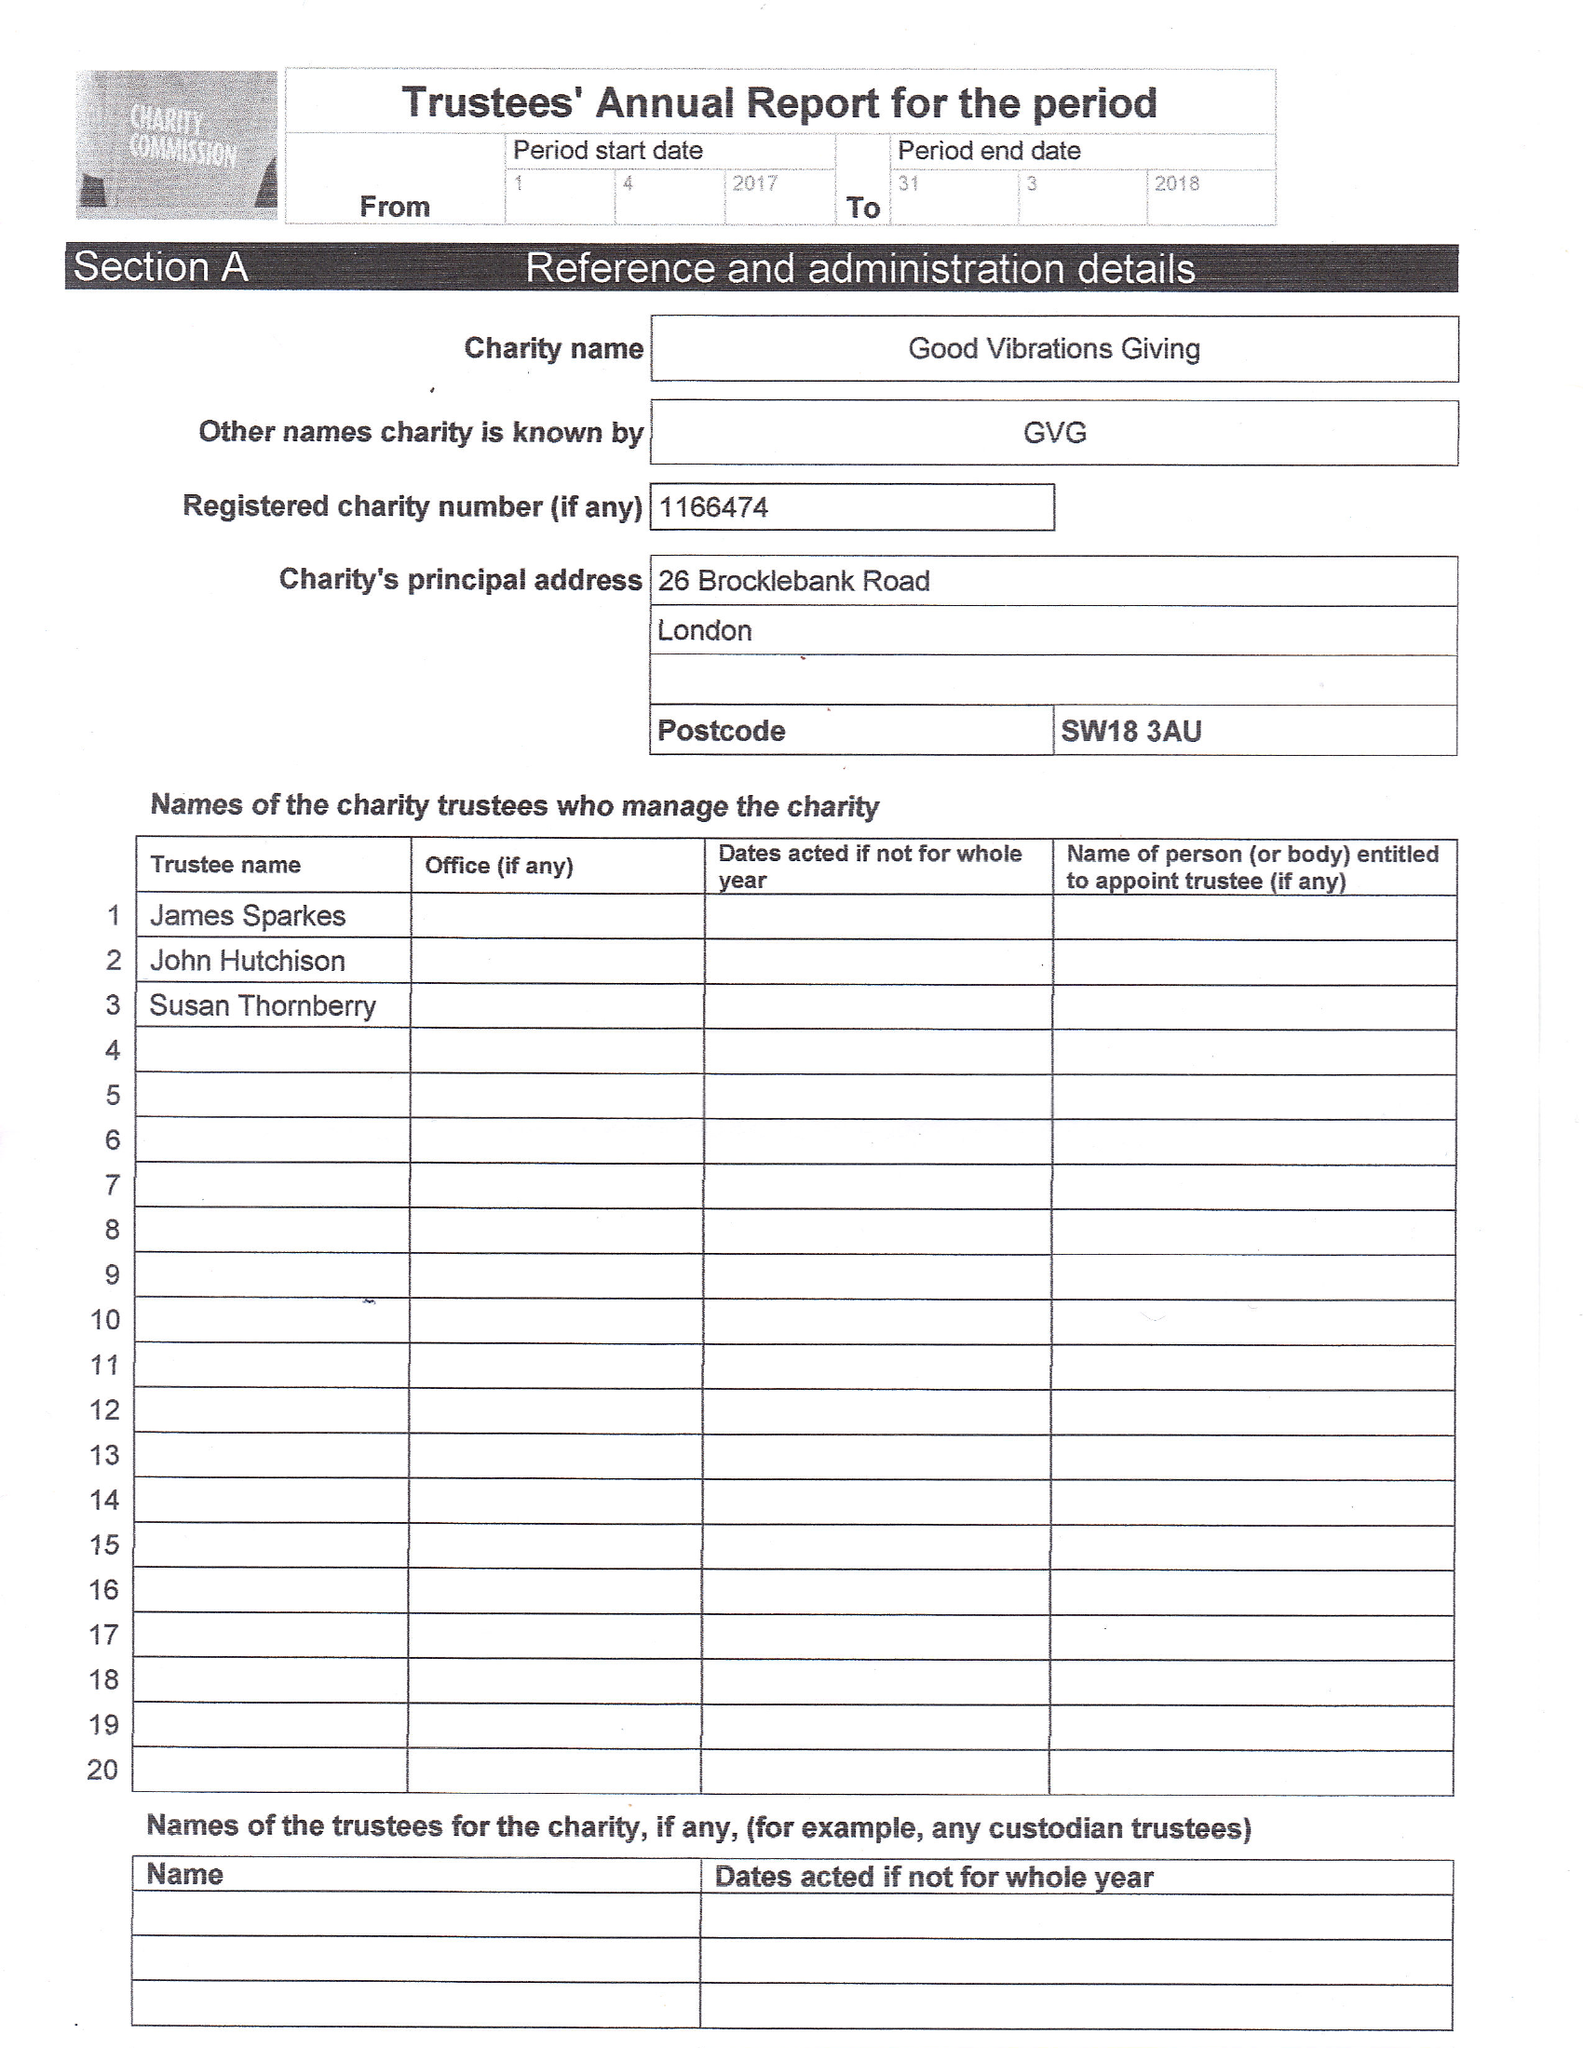What is the value for the charity_name?
Answer the question using a single word or phrase. Good Vibrations Giving 